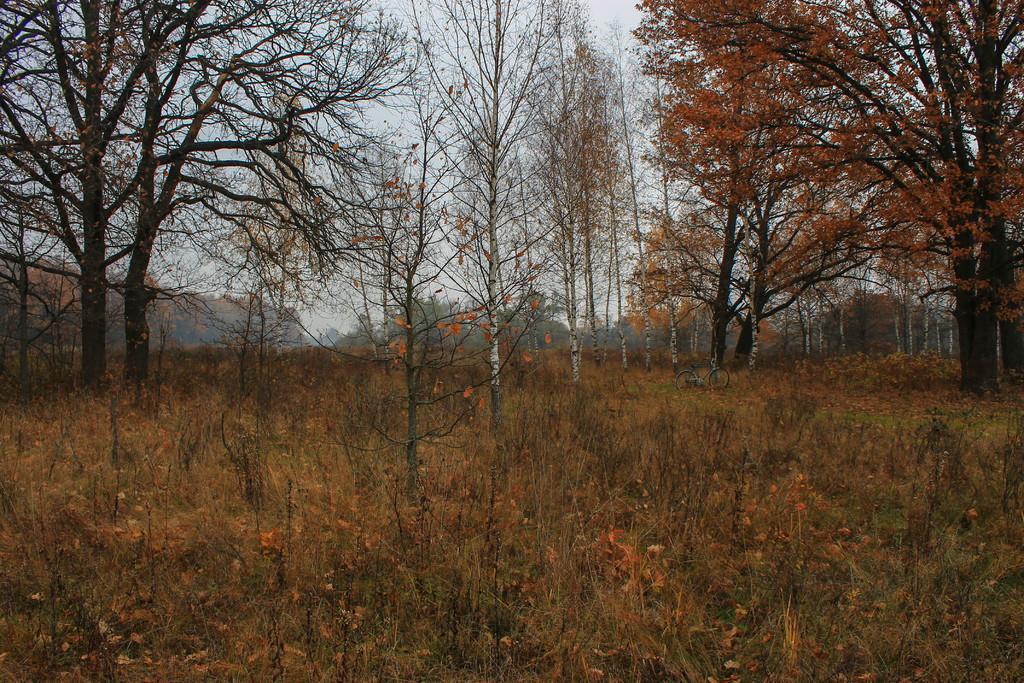Describe this image in one or two sentences. In this picture I can observe some plants on the ground there are some trees. I can observe an orange color leaves to the trees on the right side. In the background there is a sky. 